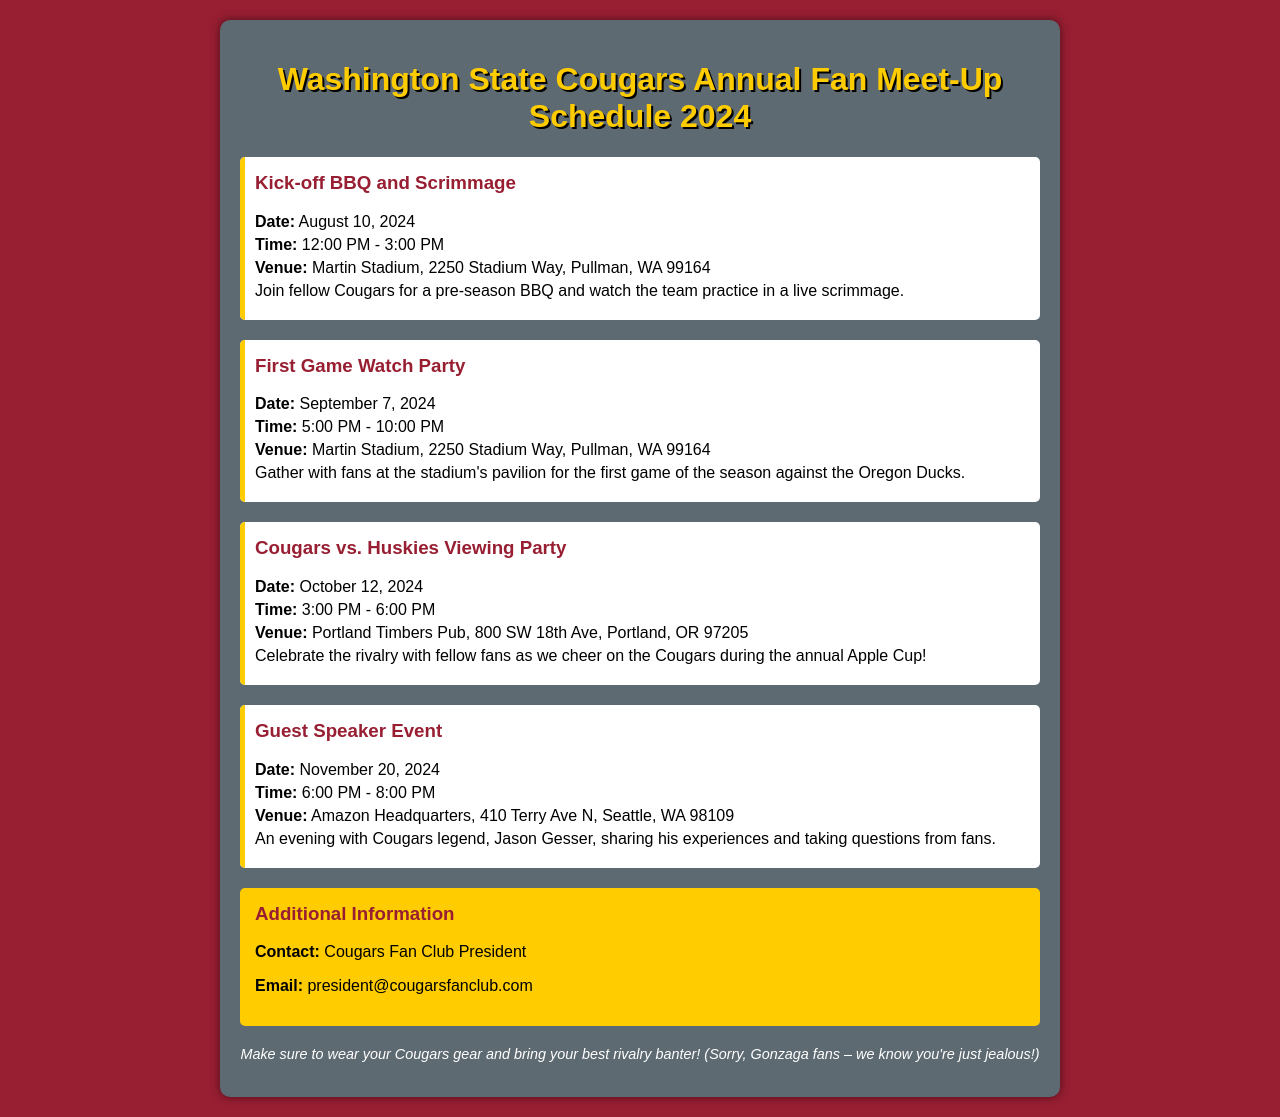What is the date of the Kick-off BBQ and Scrimmage? The date is specifically mentioned in the document as August 10, 2024.
Answer: August 10, 2024 Where is the First Game Watch Party held? The venue for the First Game Watch Party is detailed in the document as Martin Stadium, Pullman, WA.
Answer: Martin Stadium, Pullman, WA What time does the Cougars vs. Huskies Viewing Party start? The start time is provided in the document as 3:00 PM.
Answer: 3:00 PM Who is the guest speaker at the Guest Speaker Event? The document states that Cougars legend, Jason Gesser, will be the guest speaker.
Answer: Jason Gesser How long is the First Game Watch Party scheduled for? The duration is specified in the document as 5 hours, from 5:00 PM to 10:00 PM.
Answer: 5 hours What is the theme of the document? The document outlines the schedule for the Washington State Cougars Annual Fan Meet-Up events.
Answer: Annual Fan Meet-Up What is the color scheme used for the document? The document predominantly features Cougars colors like crimson and gold, with backgrounds and text that reflect this theme.
Answer: Crimson and gold How can fans contact the Cougars Fan Club President? The document provides contact information as an email address: president@cougarsfanclub.com.
Answer: president@cougarsfanclub.com What special note is mentioned for attendees? The fun note in the document encourages attendees to wear Cougars gear and bring their best rivalry banter.
Answer: Wear your Cougars gear and bring your best rivalry banter! 